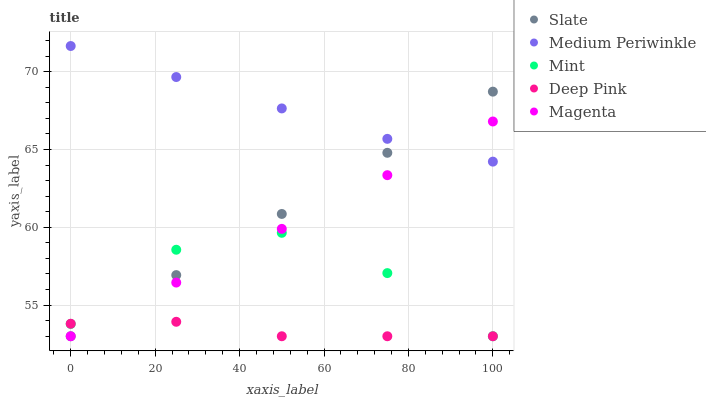Does Deep Pink have the minimum area under the curve?
Answer yes or no. Yes. Does Medium Periwinkle have the maximum area under the curve?
Answer yes or no. Yes. Does Slate have the minimum area under the curve?
Answer yes or no. No. Does Slate have the maximum area under the curve?
Answer yes or no. No. Is Magenta the smoothest?
Answer yes or no. Yes. Is Mint the roughest?
Answer yes or no. Yes. Is Slate the smoothest?
Answer yes or no. No. Is Slate the roughest?
Answer yes or no. No. Does Mint have the lowest value?
Answer yes or no. Yes. Does Medium Periwinkle have the lowest value?
Answer yes or no. No. Does Medium Periwinkle have the highest value?
Answer yes or no. Yes. Does Slate have the highest value?
Answer yes or no. No. Is Deep Pink less than Medium Periwinkle?
Answer yes or no. Yes. Is Medium Periwinkle greater than Mint?
Answer yes or no. Yes. Does Medium Periwinkle intersect Slate?
Answer yes or no. Yes. Is Medium Periwinkle less than Slate?
Answer yes or no. No. Is Medium Periwinkle greater than Slate?
Answer yes or no. No. Does Deep Pink intersect Medium Periwinkle?
Answer yes or no. No. 